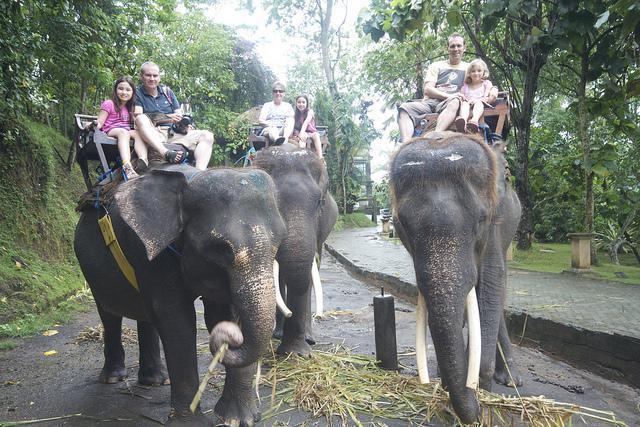How many elephants?
Give a very brief answer. 3. How many people or on each elephant?
Give a very brief answer. 2. How many elephants are visible?
Give a very brief answer. 3. How many people are there?
Give a very brief answer. 3. 